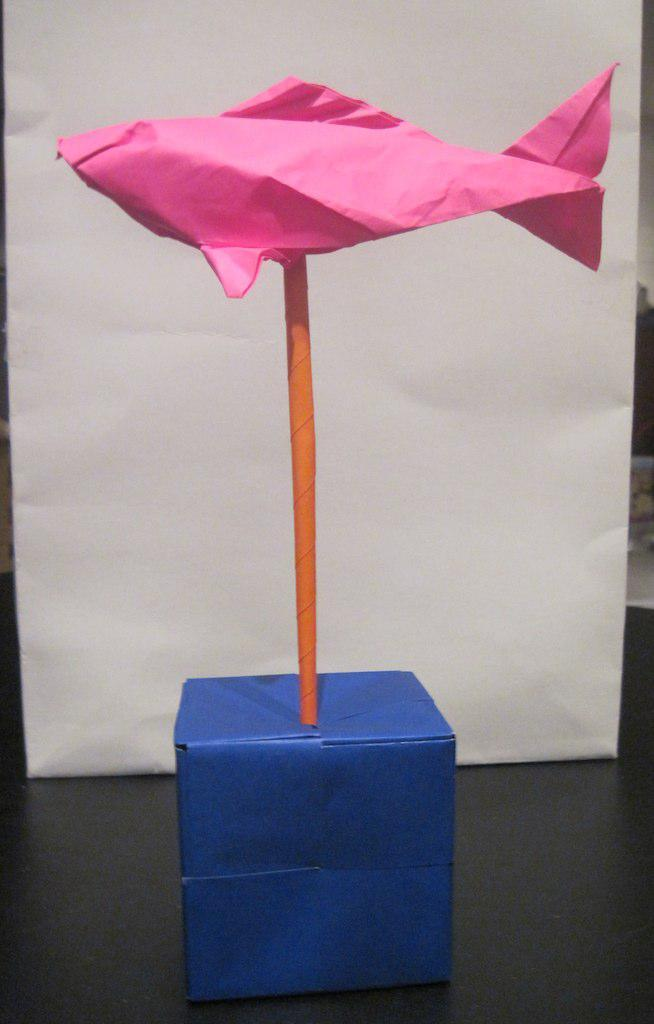What is the main subject of the image? The main subject of the image is a fish made with paper on a pole made with paper. Where is the fish and pole located? The fish and pole are in a box. What is the box placed on? The box is on a platform. What can be seen in the background of the image? There is a whiteboard in the background of the image. Where is the whiteboard placed? The whiteboard is on a platform. What type of discussion is taking place in the image? There is no discussion taking place in the image; it is a still image of a paper fish and pole in a box. What company is responsible for creating the paper fish and pole? There is no information about a company responsible for creating the paper fish and pole in the image. 